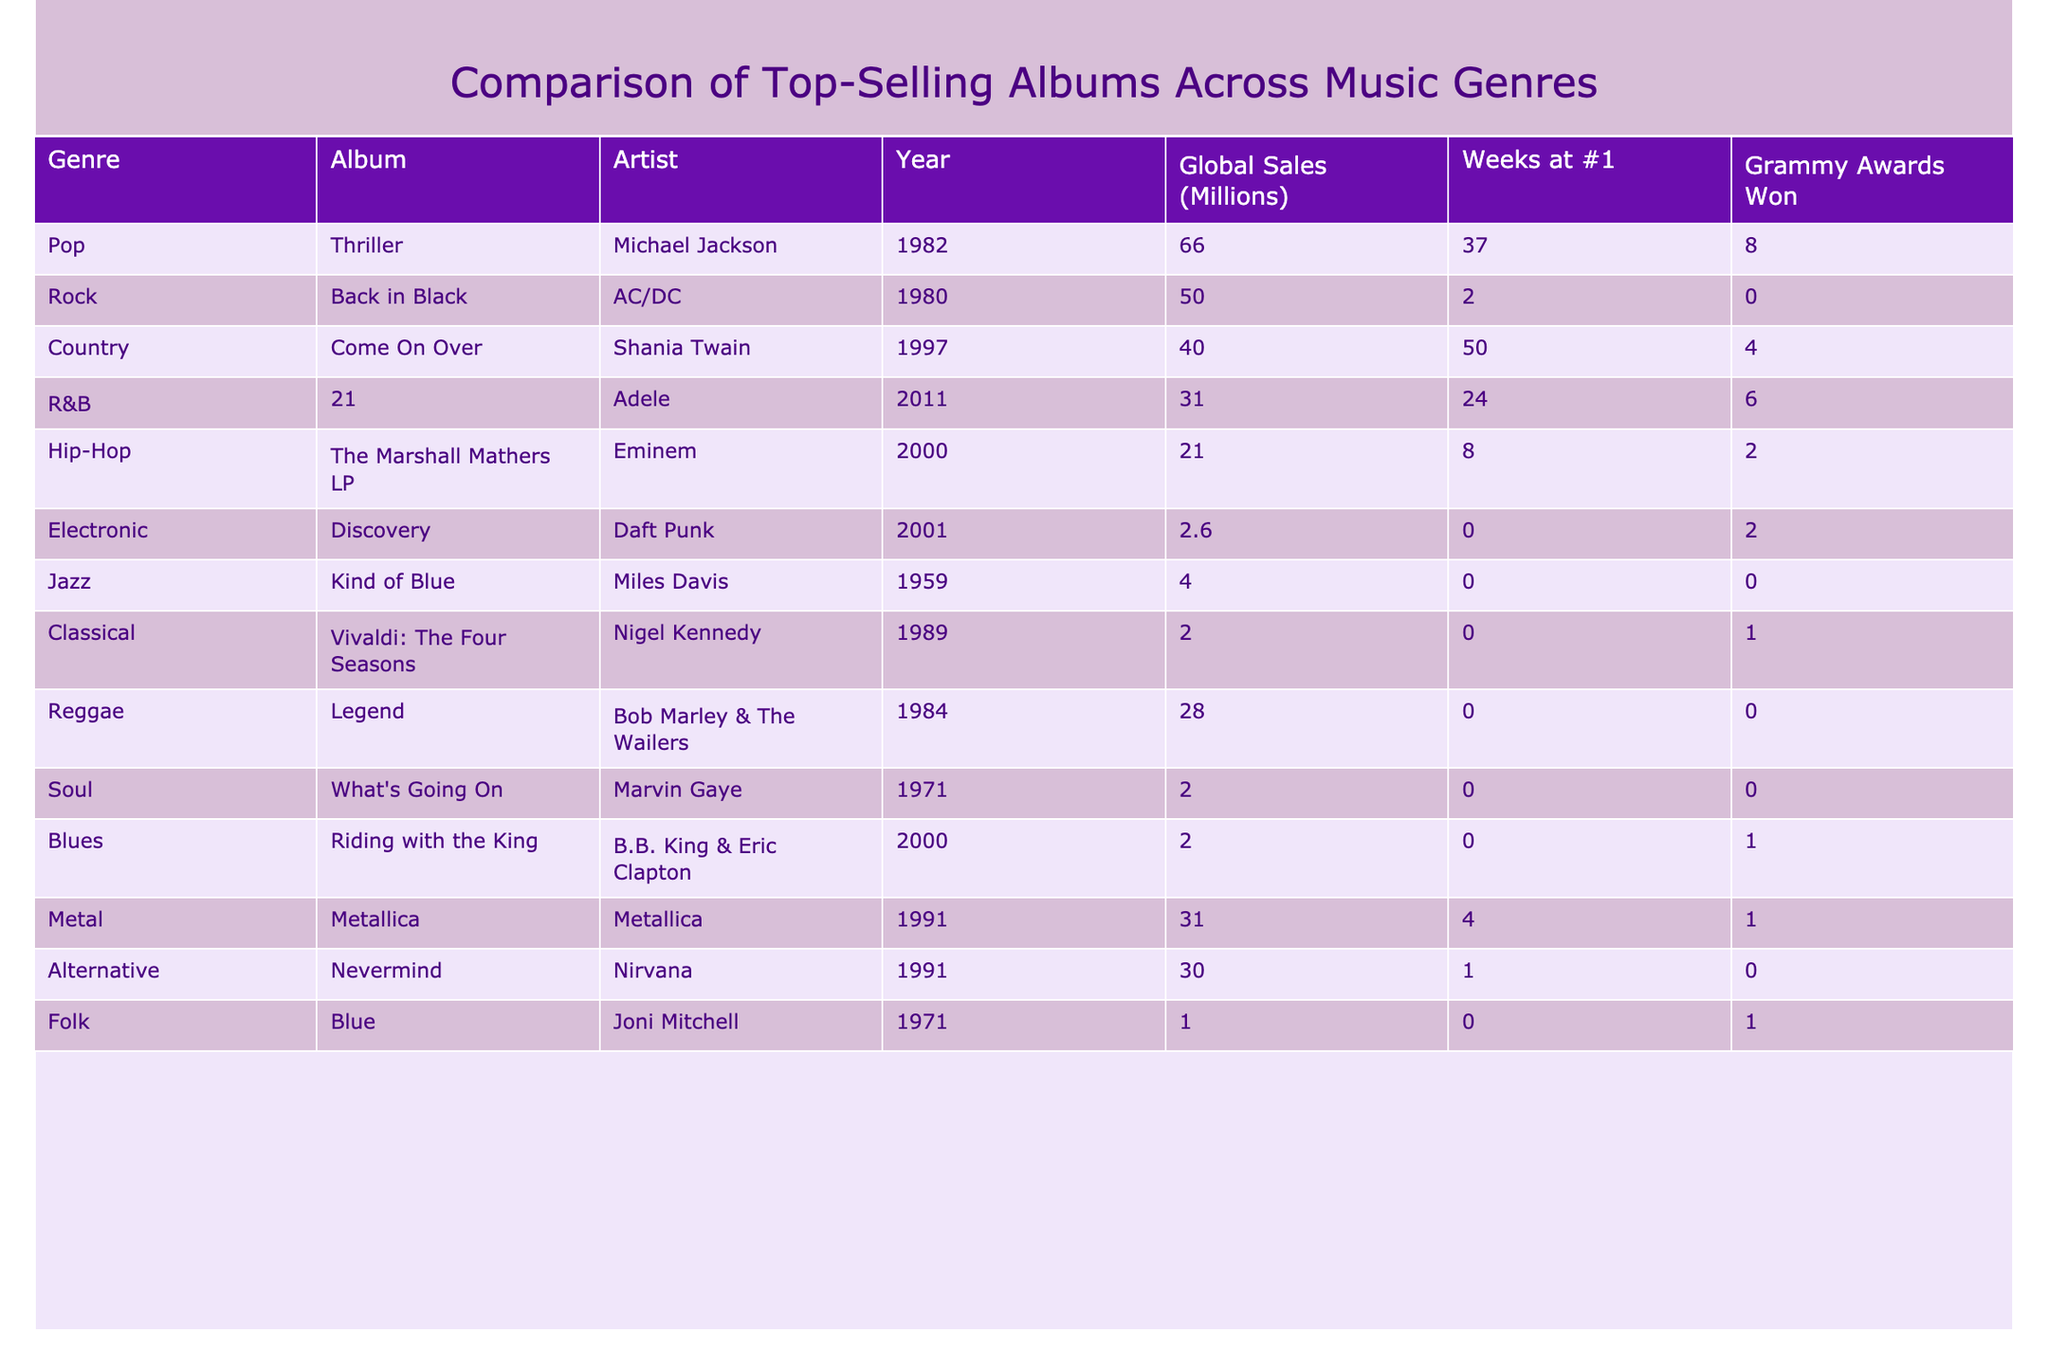What is the highest global sales figure among the albums listed? The table shows global sales figures for all albums. The album "Thriller" by Michael Jackson has the highest sales at 66 million.
Answer: 66 million Which artist won the most Grammy Awards among the top-selling albums? By looking at the "Grammy Awards Won" column, Michael Jackson has won 8 Grammy Awards for "Thriller," which is the highest in the table.
Answer: Michael Jackson How many weeks did "Come On Over" by Shania Twain spend at #1? The table indicates that "Come On Over" spent 50 weeks at #1, making it the album with the longest run at the top spot among the albums listed.
Answer: 50 weeks Which genre has the album with the lowest global sales? The entry for electronic music states that "Discovery" by Daft Punk has global sales of 2.6 million, which is the lowest among all genres listed in the table.
Answer: Electronic What is the total number of Grammy Awards won by albums in the country genre? The country album "Come On Over" won 4 Grammy Awards, while there are no other country albums listed, making the total 4.
Answer: 4 Is "The Marshall Mathers LP" by Eminem a top-selling album in terms of global sales when compared to "21" by Adele? Comparing their global sales, "21" has 31 million while "The Marshall Mathers LP" has 21 million, so "21" has higher sales.
Answer: No Which album has the second-highest global sales figure? The global sales figures show that "Back in Black" by AC/DC with 50 million is the second-highest album after "Thriller" (66 million).
Answer: Back in Black What are the combined global sales of all the albums listed under rock and metal genres? Summing the global sales of "Back in Black" (50 million) and "Metallica" (31 million) gives a total of 81 million in combined sales for those genres.
Answer: 81 million Do any R&B albums appear on the list with more than 30 million global sales? The R&B album "21" by Adele has exactly 31 million in global sales, thus meeting the criteria of being above 30 million.
Answer: Yes 